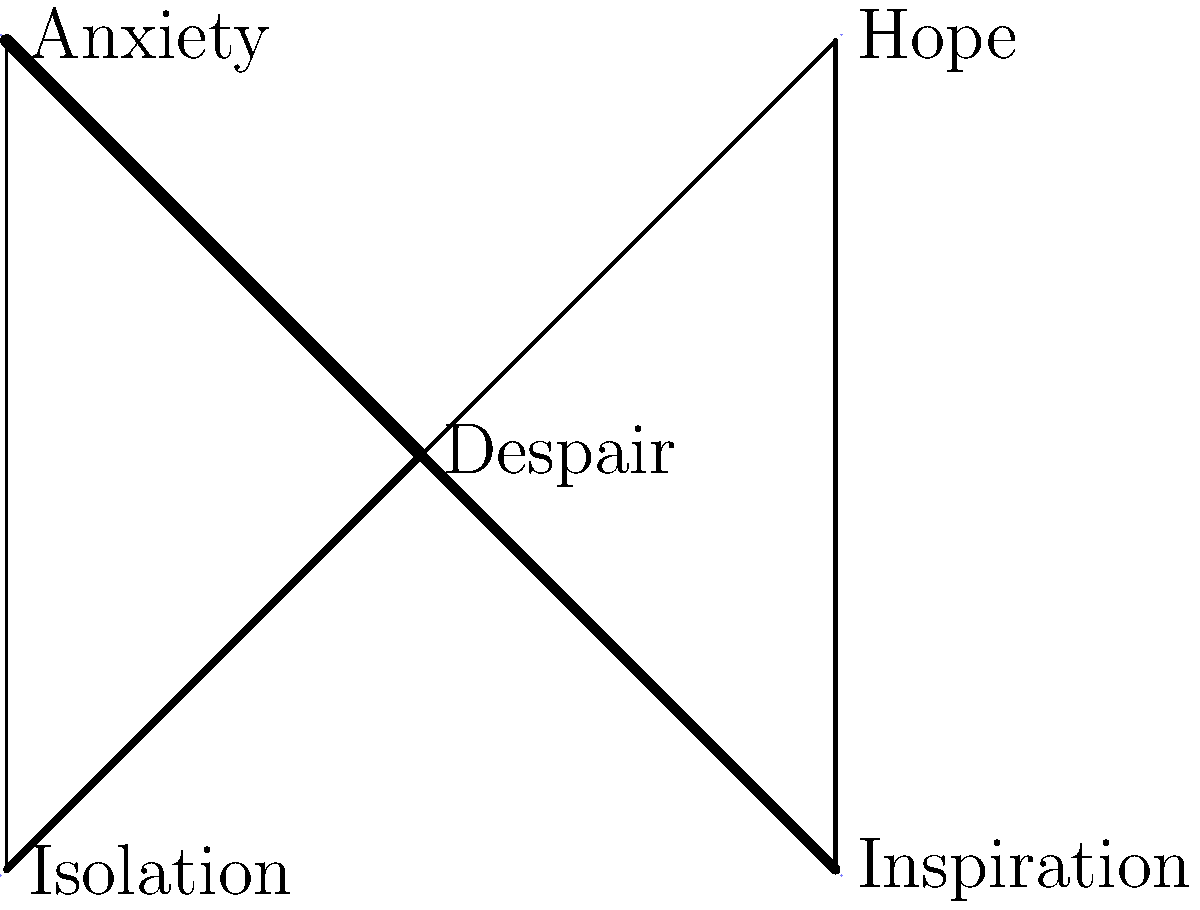In the network diagram representing your emotional landscape, which emotion appears to have the strongest connection to "Despair," and what might this suggest about your artistic journey? To answer this question, we need to analyze the connections (edges) between the central node "Despair" and the surrounding emotions:

1. Identify all connections to "Despair":
   - Despair to Hope
   - Despair to Anxiety
   - Despair to Inspiration
   - Despair to Isolation

2. Compare the thickness of the edges:
   - The thickest edge connects "Despair" to "Anxiety"
   - The second thickest edge connects "Despair" to "Inspiration"
   - The edge to "Isolation" is of medium thickness
   - The thinnest edge connects "Despair" to "Hope"

3. Interpret the strongest connection:
   The thickest edge represents the strongest connection, which is between "Despair" and "Anxiety".

4. Analyze the implication for the artistic journey:
   The strong connection between Despair and Anxiety suggests that these emotions are closely intertwined in your artistic process. This could indicate that your art is heavily influenced by feelings of worry and unease, which may serve as both a challenge and a source of creative energy.

5. Consider the role of other emotions:
   - The strong connection to Inspiration implies that despite the anxiety, your despair often leads to creative ideas.
   - The weaker connection to Hope suggests that optimism might be harder to access but still present.
   - The connection to Isolation indicates a tendency to withdraw, possibly to focus on your art.
Answer: Anxiety; it suggests a creatively challenging emotional state driving the artistic process. 